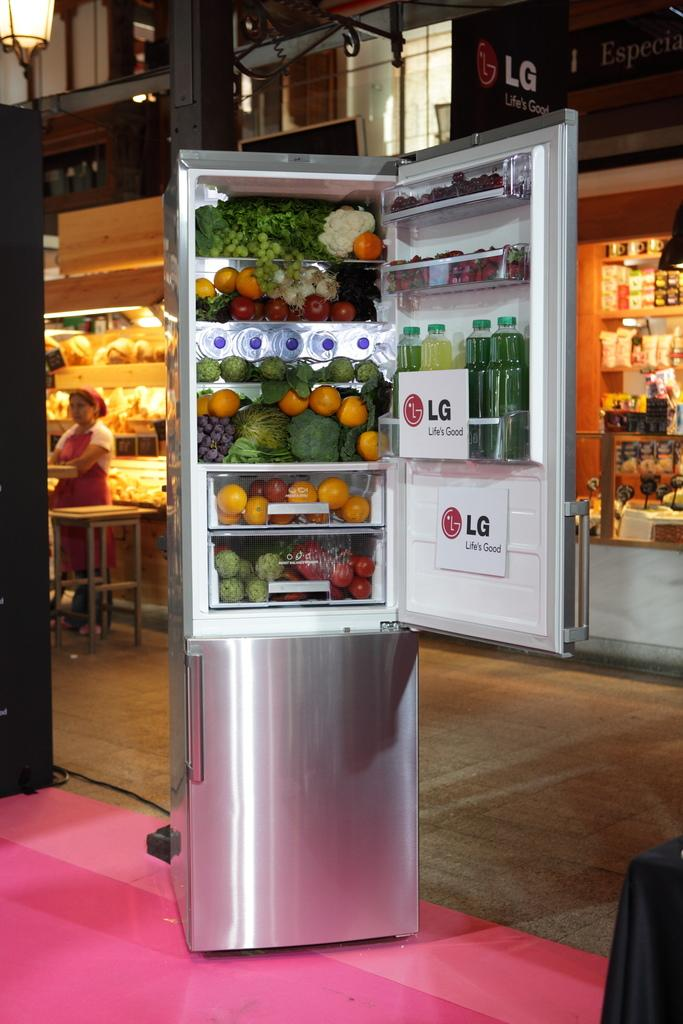<image>
Provide a brief description of the given image. An LG refrigerator with lots of fresh produce in it. 